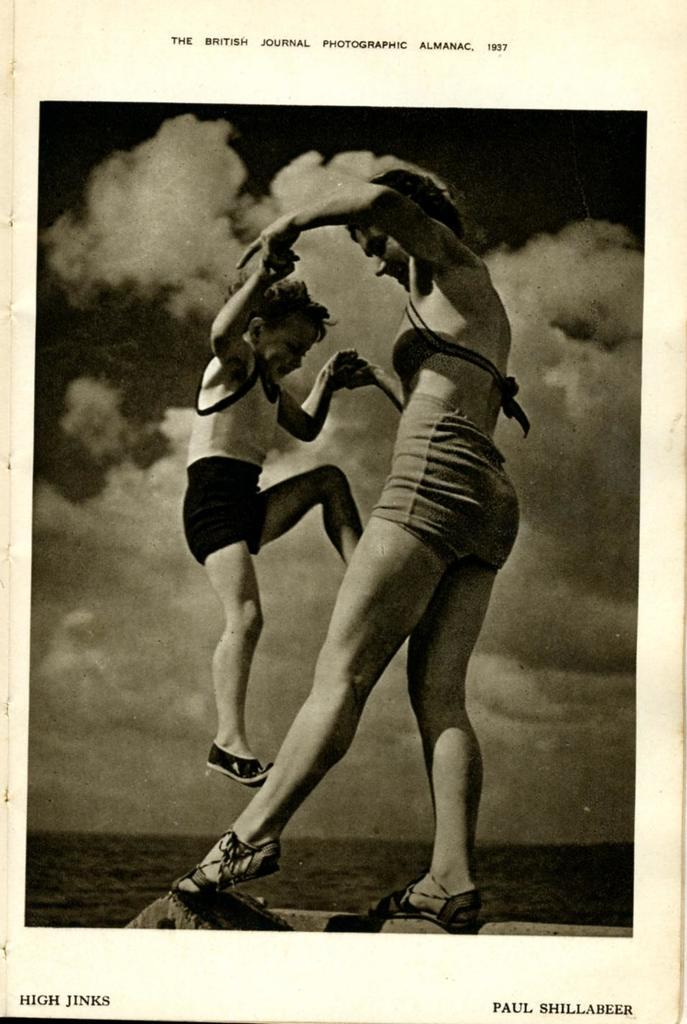What is the color scheme of the photograph? The photograph is black and white. What is the main subject of the photograph? The photograph depicts a woman holding a boy with two hands. What can be seen in the background of the photograph? There is a sky visible in the background of the photograph. What is the condition of the sky in the photograph? Clouds are present in the sky. Can you see any men attempting to board an airplane in the photograph? No, there are no men or airplanes present in the photograph. The image only shows a woman holding a boy with two hands against a sky background with clouds. 